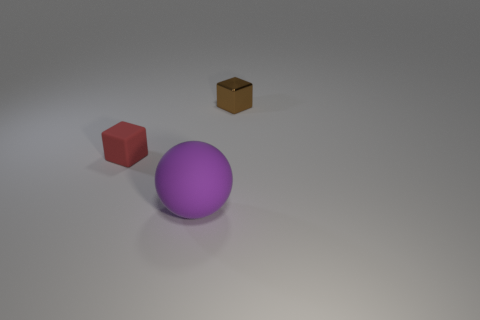Is there any other thing that is the same size as the purple sphere?
Your response must be concise. No. Is there anything else that is the same shape as the purple matte object?
Your answer should be very brief. No. There is a big sphere that is made of the same material as the tiny red thing; what color is it?
Offer a very short reply. Purple. Are there any tiny metal cubes on the right side of the rubber object to the right of the tiny cube in front of the tiny metallic thing?
Provide a succinct answer. Yes. Are there fewer small red blocks that are left of the tiny red rubber cube than red blocks on the left side of the ball?
Offer a terse response. Yes. What number of big cyan cylinders have the same material as the big purple thing?
Keep it short and to the point. 0. Do the brown metallic block and the rubber thing that is behind the large matte ball have the same size?
Your response must be concise. Yes. There is a rubber ball in front of the small block that is to the right of the rubber object on the left side of the ball; how big is it?
Give a very brief answer. Large. Are there more purple balls that are behind the brown object than purple matte objects that are on the left side of the tiny red thing?
Offer a terse response. No. How many small rubber things are behind the block left of the purple matte object?
Provide a short and direct response. 0. 